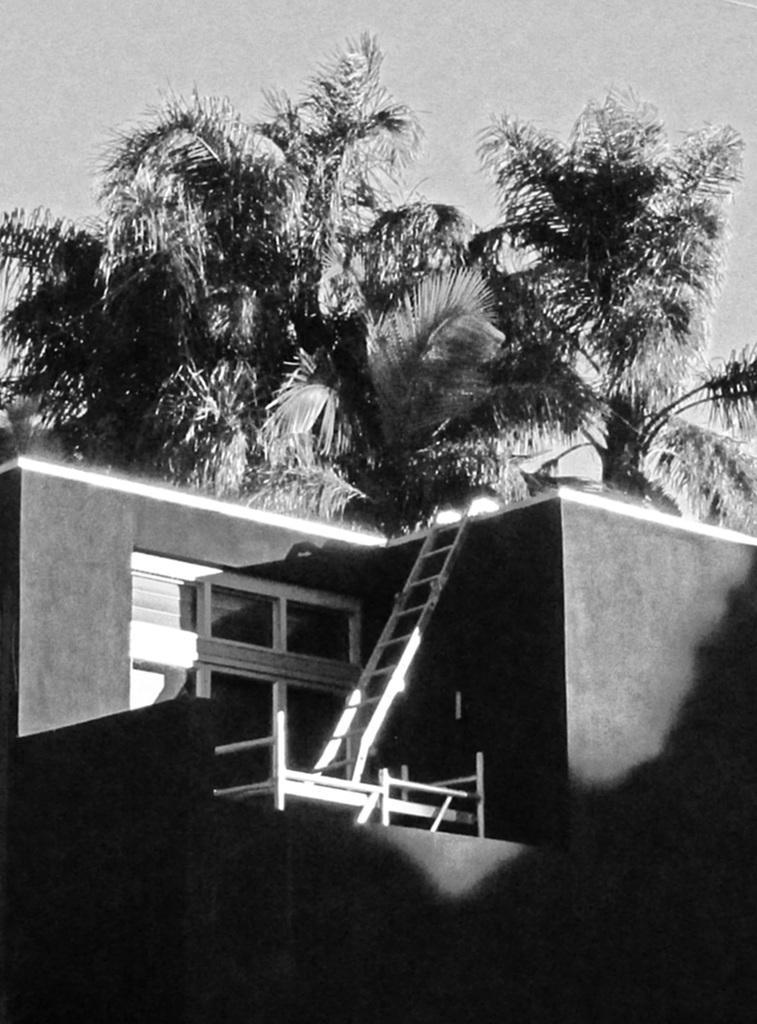Please provide a concise description of this image. In this picture I can see a building and a ladder and I can see trees. 